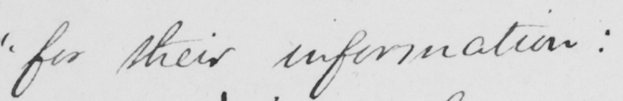Can you tell me what this handwritten text says? " for their information : 